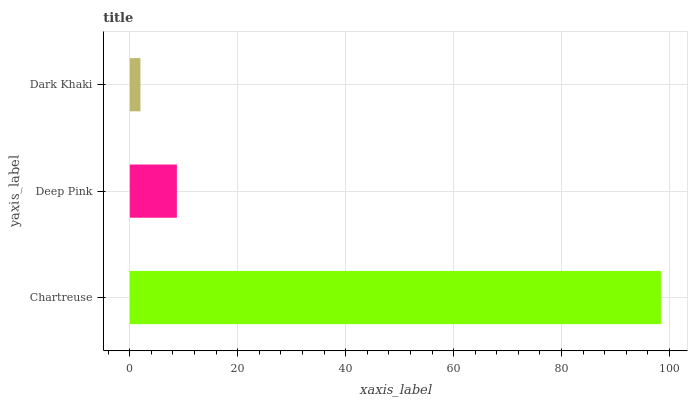Is Dark Khaki the minimum?
Answer yes or no. Yes. Is Chartreuse the maximum?
Answer yes or no. Yes. Is Deep Pink the minimum?
Answer yes or no. No. Is Deep Pink the maximum?
Answer yes or no. No. Is Chartreuse greater than Deep Pink?
Answer yes or no. Yes. Is Deep Pink less than Chartreuse?
Answer yes or no. Yes. Is Deep Pink greater than Chartreuse?
Answer yes or no. No. Is Chartreuse less than Deep Pink?
Answer yes or no. No. Is Deep Pink the high median?
Answer yes or no. Yes. Is Deep Pink the low median?
Answer yes or no. Yes. Is Dark Khaki the high median?
Answer yes or no. No. Is Chartreuse the low median?
Answer yes or no. No. 